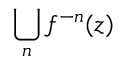<formula> <loc_0><loc_0><loc_500><loc_500>\bigcup _ { n } f ^ { - n } ( z )</formula> 